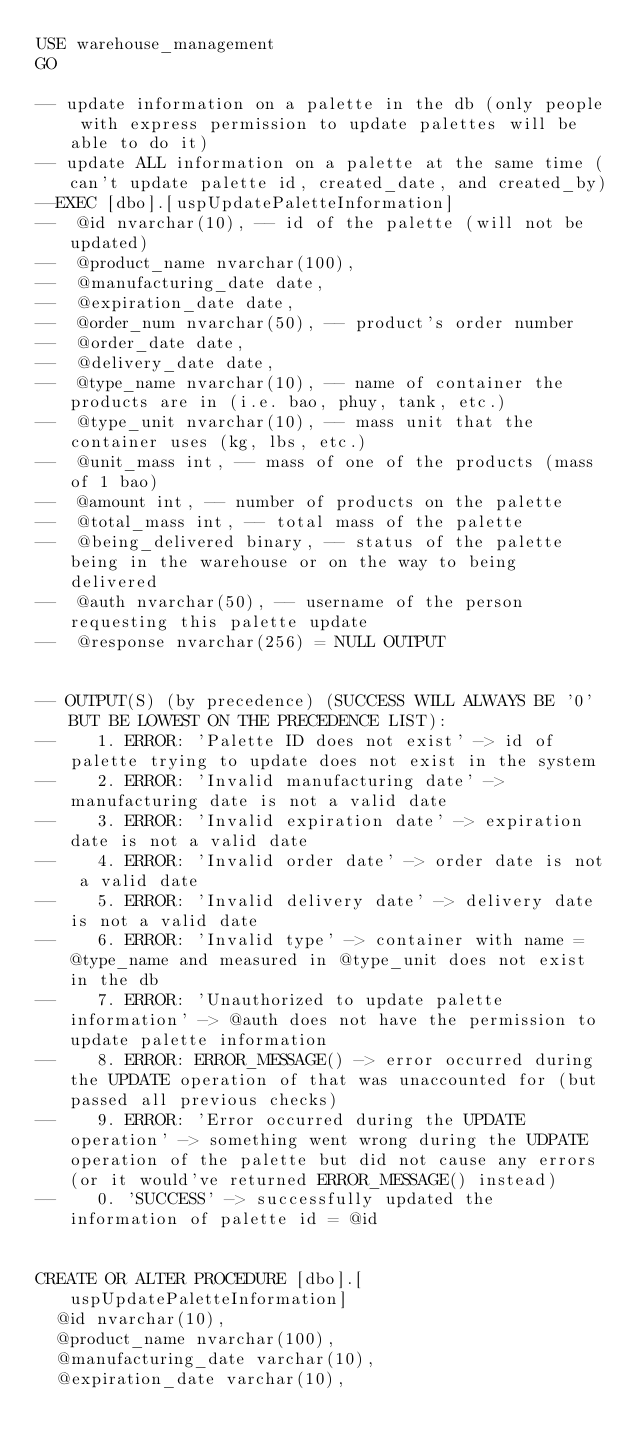Convert code to text. <code><loc_0><loc_0><loc_500><loc_500><_SQL_>USE warehouse_management
GO

-- update information on a palette in the db (only people with express permission to update palettes will be able to do it)
-- update ALL information on a palette at the same time (can't update palette id, created_date, and created_by)
--EXEC [dbo].[uspUpdatePaletteInformation]
--	@id nvarchar(10), -- id of the palette (will not be updated)
--	@product_name nvarchar(100),
--	@manufacturing_date date,
--	@expiration_date date,
--	@order_num nvarchar(50), -- product's order number
--	@order_date date,
--	@delivery_date date,
--	@type_name nvarchar(10), -- name of container the products are in (i.e. bao, phuy, tank, etc.)
--	@type_unit nvarchar(10), -- mass unit that the container uses (kg, lbs, etc.)
--	@unit_mass int, -- mass of one of the products (mass of 1 bao)
--	@amount int, -- number of products on the palette
--	@total_mass int, -- total mass of the palette
--	@being_delivered binary, -- status of the palette being in the warehouse or on the way to being delivered
--	@auth nvarchar(50), -- username of the person requesting this palette update
--	@response nvarchar(256) = NULL OUTPUT


-- OUTPUT(S) (by precedence) (SUCCESS WILL ALWAYS BE '0' BUT BE LOWEST ON THE PRECEDENCE LIST):
--		1. ERROR: 'Palette ID does not exist' -> id of palette trying to update does not exist in the system
--		2. ERROR: 'Invalid manufacturing date' -> manufacturing date is not a valid date
--		3. ERROR: 'Invalid expiration date' -> expiration date is not a valid date
--		4. ERROR: 'Invalid order date' -> order date is not a valid date
--		5. ERROR: 'Invalid delivery date' -> delivery date is not a valid date
--		6. ERROR: 'Invalid type' -> container with name = @type_name and measured in @type_unit does not exist in the db
--		7. ERROR: 'Unauthorized to update palette information' -> @auth does not have the permission to update palette information
--		8. ERROR: ERROR_MESSAGE() -> error occurred during the UPDATE operation of that was unaccounted for (but passed all previous checks)
--		9. ERROR: 'Error occurred during the UPDATE operation' -> something went wrong during the UDPATE operation of the palette but did not cause any errors (or it would've returned ERROR_MESSAGE() instead)
--		0. 'SUCCESS' -> successfully updated the information of palette id = @id


CREATE OR ALTER PROCEDURE [dbo].[uspUpdatePaletteInformation]
	@id nvarchar(10),
	@product_name nvarchar(100),
	@manufacturing_date varchar(10),
	@expiration_date varchar(10),</code> 